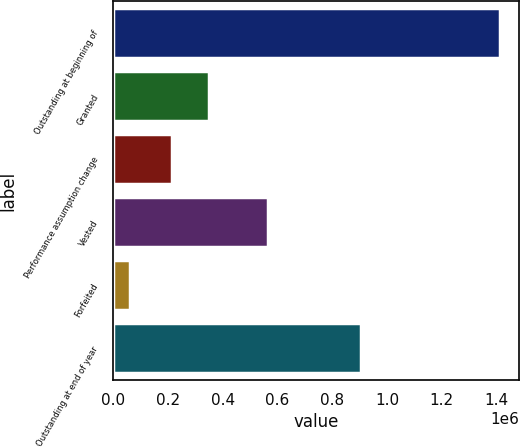Convert chart. <chart><loc_0><loc_0><loc_500><loc_500><bar_chart><fcel>Outstanding at beginning of<fcel>Granted<fcel>Performance assumption change<fcel>Vested<fcel>Forfeited<fcel>Outstanding at end of year<nl><fcel>1.4114e+06<fcel>349363<fcel>214145<fcel>565520<fcel>59216<fcel>904306<nl></chart> 